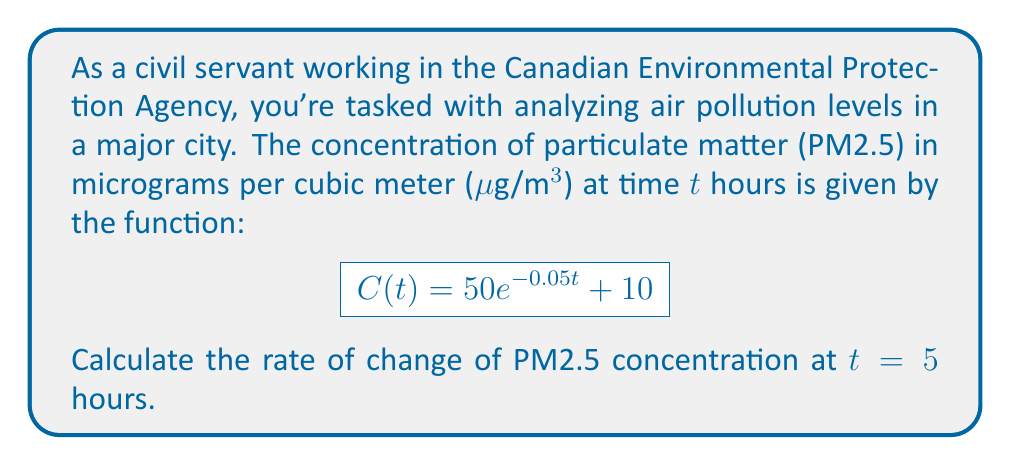Show me your answer to this math problem. To solve this problem, we need to follow these steps:

1) The rate of change of concentration with respect to time is given by the derivative of $C(t)$. Let's call this $C'(t)$.

2) To find $C'(t)$, we use the derivative rules:
   
   $$C'(t) = \frac{d}{dt}[50e^{-0.05t} + 10]$$

3) The derivative of a constant (10) is 0, and we use the chain rule for $e^{-0.05t}$:
   
   $$C'(t) = 50 \cdot (-0.05) \cdot e^{-0.05t} + 0$$

4) Simplify:
   
   $$C'(t) = -2.5e^{-0.05t}$$

5) Now, we need to evaluate this at $t = 5$:
   
   $$C'(5) = -2.5e^{-0.05(5)} = -2.5e^{-0.25}$$

6) Calculate the value:
   
   $$C'(5) = -2.5 \cdot 0.7788 = -1.947$$

The negative value indicates that the concentration is decreasing at this time.
Answer: $-1.947$ μg/m³ per hour 